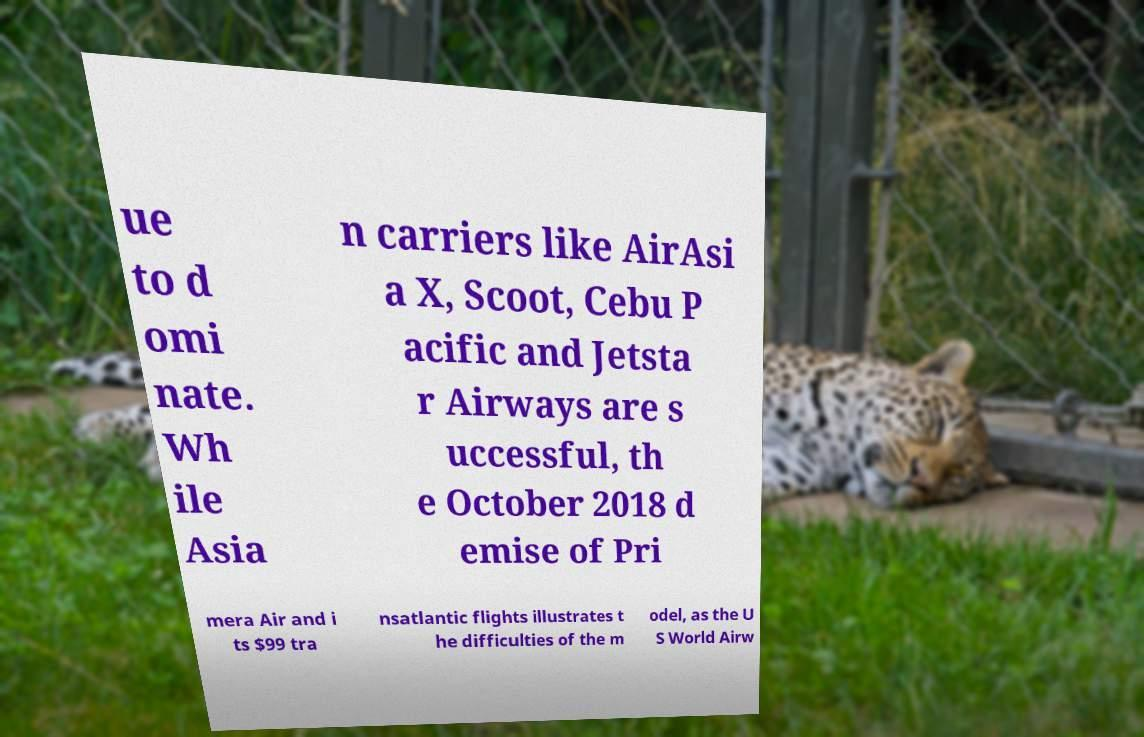Please read and relay the text visible in this image. What does it say? ue to d omi nate. Wh ile Asia n carriers like AirAsi a X, Scoot, Cebu P acific and Jetsta r Airways are s uccessful, th e October 2018 d emise of Pri mera Air and i ts $99 tra nsatlantic flights illustrates t he difficulties of the m odel, as the U S World Airw 